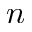Convert formula to latex. <formula><loc_0><loc_0><loc_500><loc_500>n</formula> 